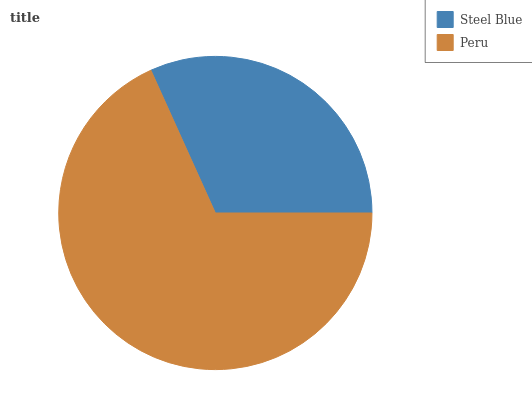Is Steel Blue the minimum?
Answer yes or no. Yes. Is Peru the maximum?
Answer yes or no. Yes. Is Peru the minimum?
Answer yes or no. No. Is Peru greater than Steel Blue?
Answer yes or no. Yes. Is Steel Blue less than Peru?
Answer yes or no. Yes. Is Steel Blue greater than Peru?
Answer yes or no. No. Is Peru less than Steel Blue?
Answer yes or no. No. Is Peru the high median?
Answer yes or no. Yes. Is Steel Blue the low median?
Answer yes or no. Yes. Is Steel Blue the high median?
Answer yes or no. No. Is Peru the low median?
Answer yes or no. No. 